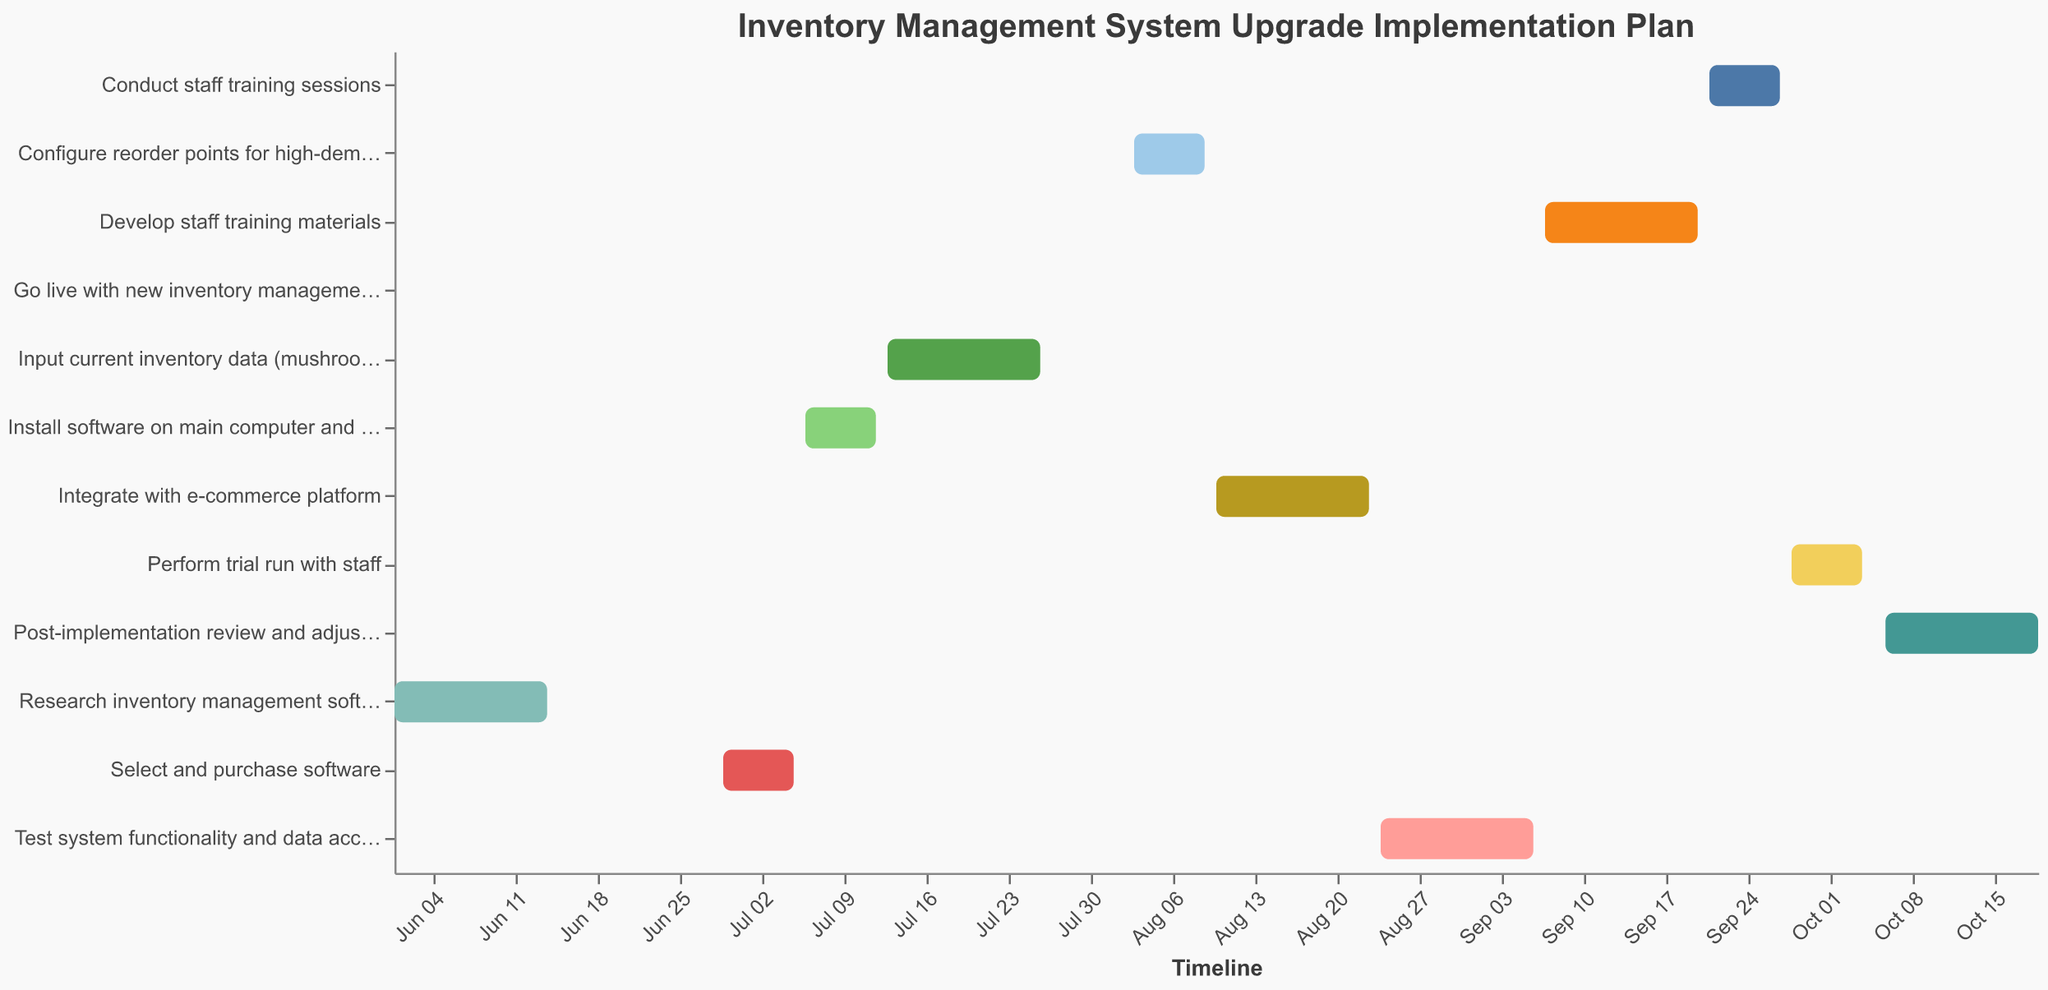What's the duration of the "Develop staff training materials" task? Locate the bar corresponding to "Develop staff training materials", and refer to the "Duration (days)" in the tooltip, which is 14 days.
Answer: 14 days How many days after "Research inventory management software options" ends does "Select and purchase software" start? The "Research inventory management software options" ends on June 14, and "Select and purchase software" starts on June 29. Calculate the difference: June 29 - June 14 = 15 days.
Answer: 15 days Which task lasts for the shortest duration? From the tooltip information, observe the duration of each task. The "Go live with new inventory management system" task has the shortest duration, lasting only 1 day.
Answer: Go live with new inventory management system Which tasks overlap time-wise? Visually inspecting the bars on the timeline, the "Test system functionality and data accuracy" task overlaps slightly with the "Develop staff training materials." Both the integration with the e-commerce platform and the testing system tasks overlap.
Answer: Test system functionality and data accuracy, Develop staff training materials What is the total duration from the start of the first task to the end of the last task? The first task, "Research inventory management software options," starts on June 1, and the last task, "Post-implementation review and adjustments," ends on October 19. Calculate the duration by counting the days between these dates, which totals 140 days.
Answer: 140 days How long does it take to complete the "Integrate with e-commerce platform" task and the subsequent "Test system functionality and data accuracy" task? Add the durations of both tasks: "Integrate with e-commerce platform" (14 days) and "Test system functionality and data accuracy" (14 days). The total duration is 14 + 14 = 28 days.
Answer: 28 days Which task starts immediately after "Input current inventory data (mushroom growing supplies)"? The "Input current inventory data (mushroom growing supplies)" task ends on July 26. The next task, "Configure reorder points for high-demand items", starts immediately after on August 3.
Answer: Configure reorder points for high-demand items Is there any gap between the end of the "Conduct staff training sessions" and the start of the "Perform trial run with staff"? The "Conduct staff training sessions" ends on September 27, and the "Perform trial run with staff" starts on September 28. There is no gap between these tasks.
Answer: No How long after the installation of the software do we begin staff training sessions? "Install software" ends on July 12, and "Conduct staff training sessions" starts on September 21. The gap between these dates is 71 days.
Answer: 71 days What tasks continue for exactly two weeks? Tasks that last for 14 days, or exactly two weeks, are "Research inventory management software options," "Input current inventory data (mushroom growing supplies)," "Integrate with e-commerce platform," "Test system functionality and data accuracy," "Develop staff training materials," and "Post-implementation review and adjustments."
Answer: Research inventory management software options, Input current inventory data (mushroom growing supplies), Integrate with e-commerce platform, Test system functionality and data accuracy, Develop staff training materials, Post-implementation review and adjustments 